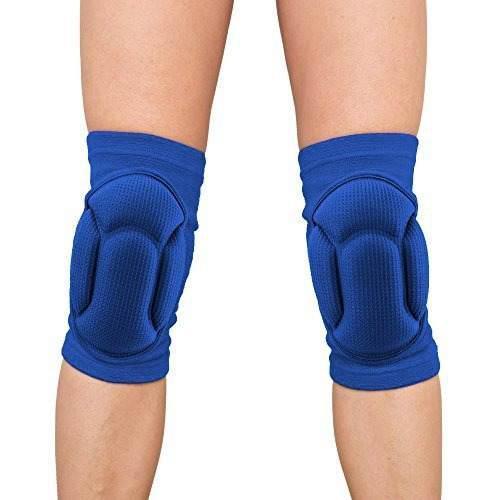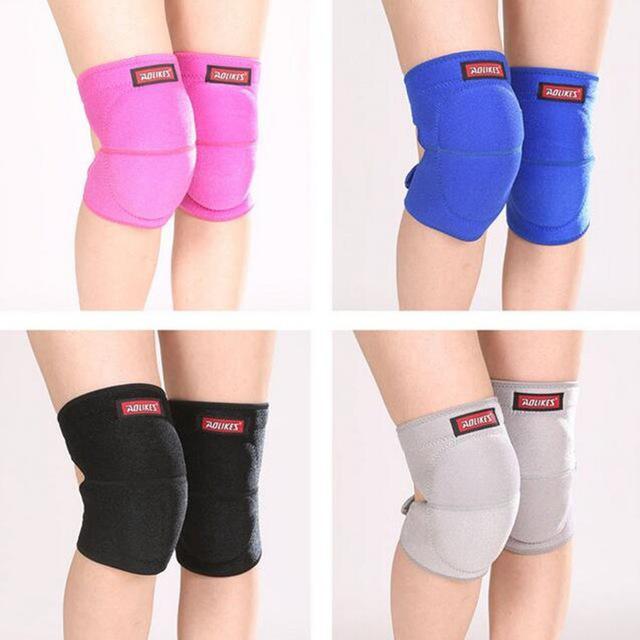The first image is the image on the left, the second image is the image on the right. Examine the images to the left and right. Is the description "There is a single blue kneepad in one image and two black kneepads in the other image." accurate? Answer yes or no. No. The first image is the image on the left, the second image is the image on the right. Given the left and right images, does the statement "Two black kneepads are modeled in one image, but a second image shows only one kneepad of a different color." hold true? Answer yes or no. No. 